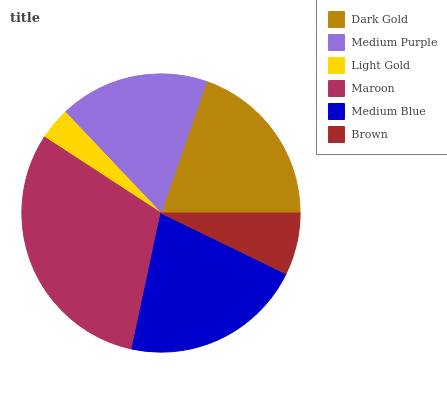Is Light Gold the minimum?
Answer yes or no. Yes. Is Maroon the maximum?
Answer yes or no. Yes. Is Medium Purple the minimum?
Answer yes or no. No. Is Medium Purple the maximum?
Answer yes or no. No. Is Dark Gold greater than Medium Purple?
Answer yes or no. Yes. Is Medium Purple less than Dark Gold?
Answer yes or no. Yes. Is Medium Purple greater than Dark Gold?
Answer yes or no. No. Is Dark Gold less than Medium Purple?
Answer yes or no. No. Is Dark Gold the high median?
Answer yes or no. Yes. Is Medium Purple the low median?
Answer yes or no. Yes. Is Medium Blue the high median?
Answer yes or no. No. Is Dark Gold the low median?
Answer yes or no. No. 